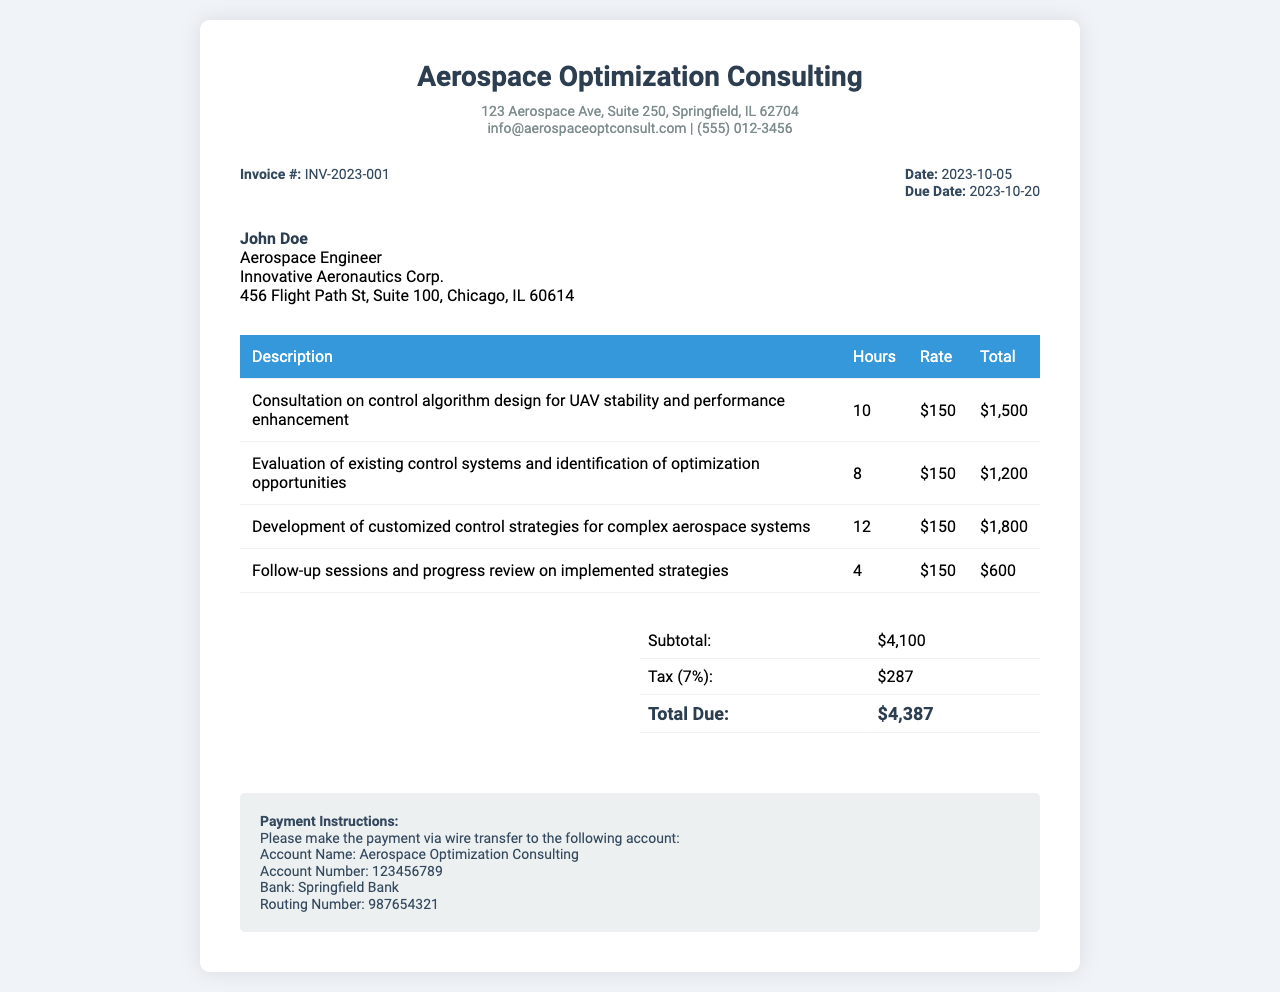What is the invoice number? The invoice number is located in the invoice details section, specified as "Invoice #: INV-2023-001".
Answer: INV-2023-001 What is the total due amount? The total due is calculated from the subtotal and tax, shown in the summary section as "Total Due: $4,387".
Answer: $4,387 Who is the client named in the invoice? The client name is mentioned in the client info section as "John Doe".
Answer: John Doe What date is the invoice issued? The issue date of the invoice is specified as "Date: 2023-10-05".
Answer: 2023-10-05 How many hours were billed for consultation on control algorithm design? The hours billed for this specific consultation are noted as "10" hours in the table.
Answer: 10 What is the rate per hour for the services? The rate per hour is consistently listed throughout the document as "$150".
Answer: $150 What is the subtotal amount before tax? The subtotal is provided in the summary section, listed as "Subtotal: $4,100".
Answer: $4,100 How many follow-up sessions are billed? The follow-up sessions are detailed in the table, which lists "4" hours for progress review.
Answer: 4 What is the tax percentage applied on the subtotal? The tax percentage is reflected in the summary as "7%".
Answer: 7% 